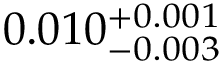Convert formula to latex. <formula><loc_0><loc_0><loc_500><loc_500>0 . 0 1 0 _ { - 0 . 0 0 3 } ^ { + 0 . 0 0 1 }</formula> 